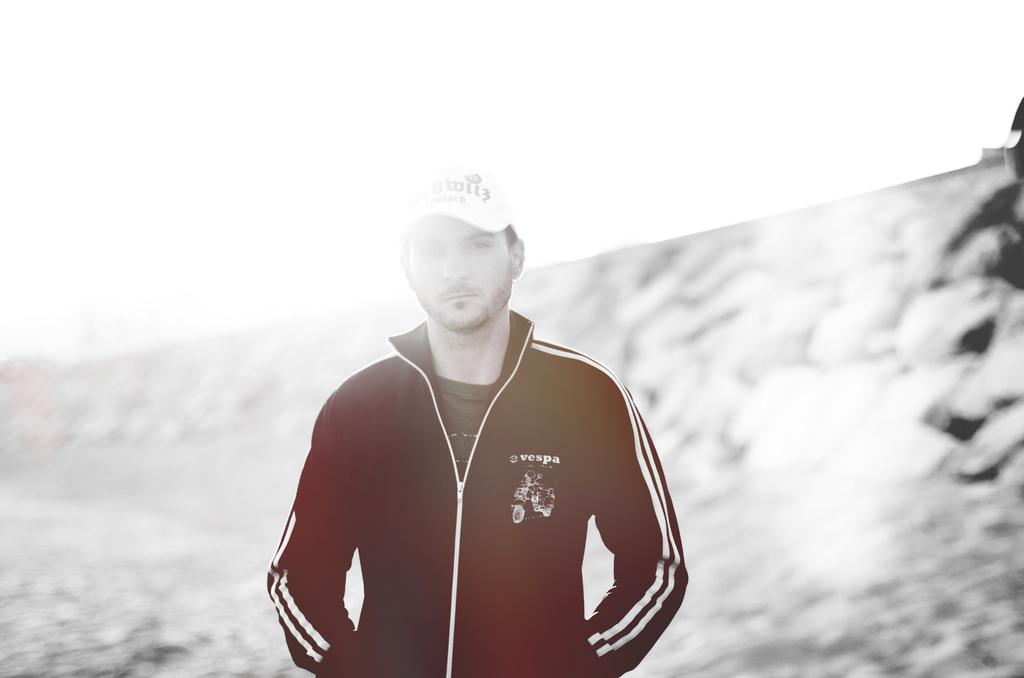What is the main subject of the image? There is a person in the image. What is the person wearing on their upper body? The person is wearing a black and white jacket. What type of headwear is the person wearing? The person is wearing a white hat. What is the person's posture in the image? The person is standing. How would you describe the background of the image? The background of the image is blurry. What type of party is the person attending in the image? There is no indication of a party in the image; it only shows a person wearing a black and white jacket and a white hat while standing. What achievement has the person recently accomplished, as seen in the image? There is no indication of an achievement or any context for the person's actions in the image. 